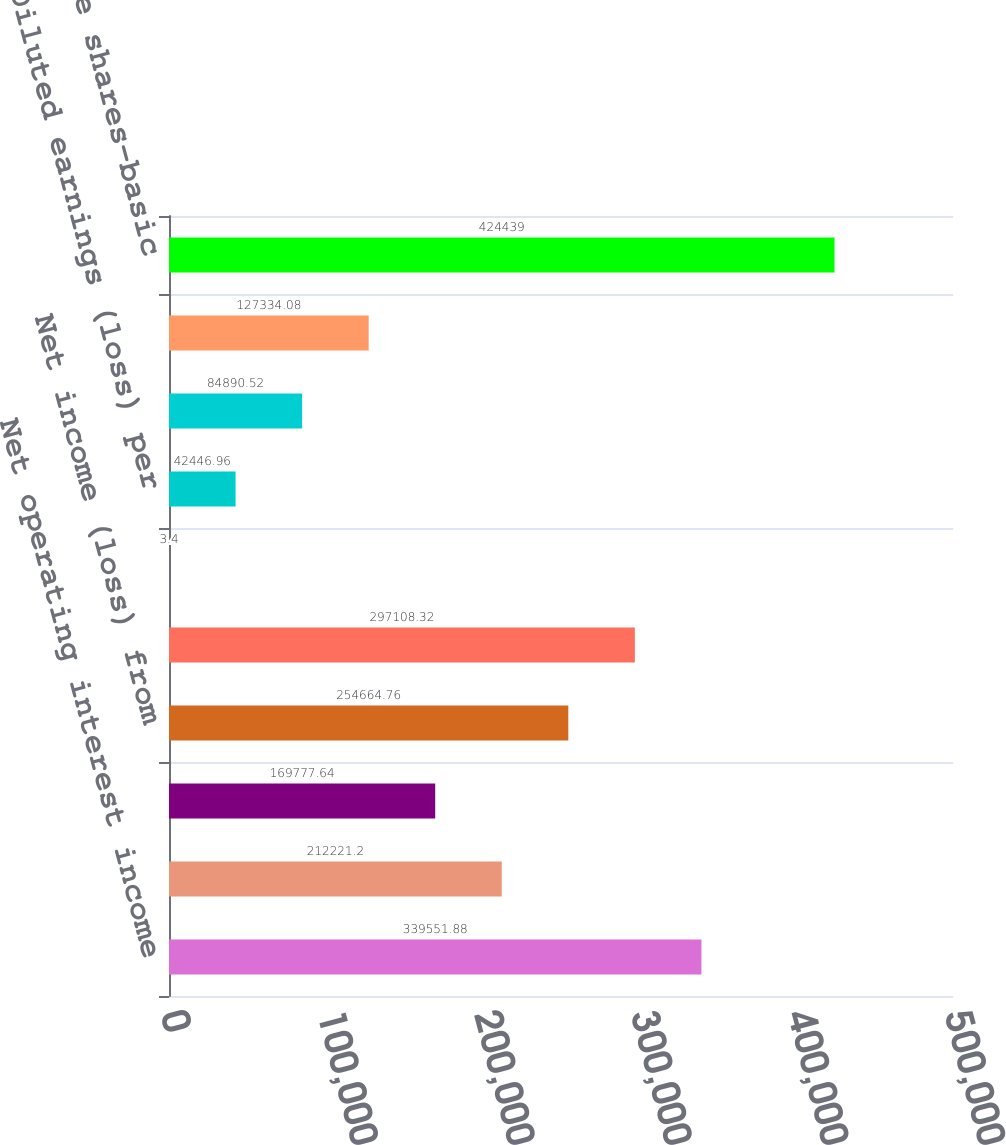Convert chart. <chart><loc_0><loc_0><loc_500><loc_500><bar_chart><fcel>Net operating interest income<fcel>Provision for loan losses (3)<fcel>Total net revenue<fcel>Net income (loss) from<fcel>Net income (loss)<fcel>Basic earnings (loss) per<fcel>Diluted earnings (loss) per<fcel>Basic net earnings (loss) per<fcel>Diluted net earnings (loss)<fcel>Weighted average shares-basic<nl><fcel>339552<fcel>212221<fcel>169778<fcel>254665<fcel>297108<fcel>3.4<fcel>42447<fcel>84890.5<fcel>127334<fcel>424439<nl></chart> 